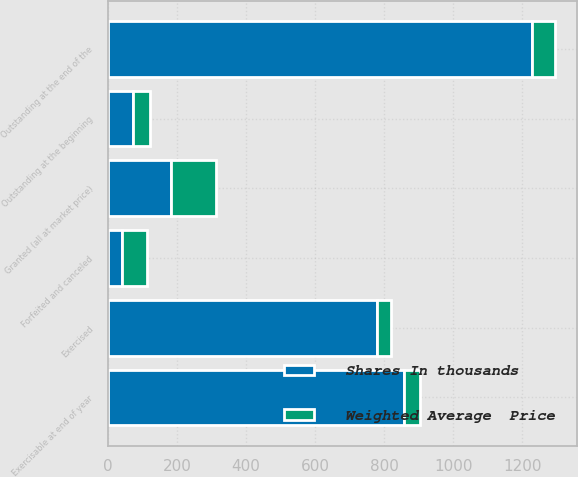<chart> <loc_0><loc_0><loc_500><loc_500><stacked_bar_chart><ecel><fcel>Outstanding at the beginning<fcel>Granted (all at market price)<fcel>Exercised<fcel>Forfeited and canceled<fcel>Outstanding at the end of the<fcel>Exercisable at end of year<nl><fcel>Shares In thousands<fcel>72.06<fcel>181<fcel>779<fcel>40<fcel>1228<fcel>856<nl><fcel>Weighted Average  Price<fcel>49.54<fcel>131.41<fcel>40.61<fcel>72.06<fcel>66.81<fcel>48.43<nl></chart> 